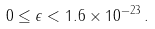Convert formula to latex. <formula><loc_0><loc_0><loc_500><loc_500>0 \leq \epsilon < 1 . 6 \times 1 0 ^ { - 2 3 } \, .</formula> 